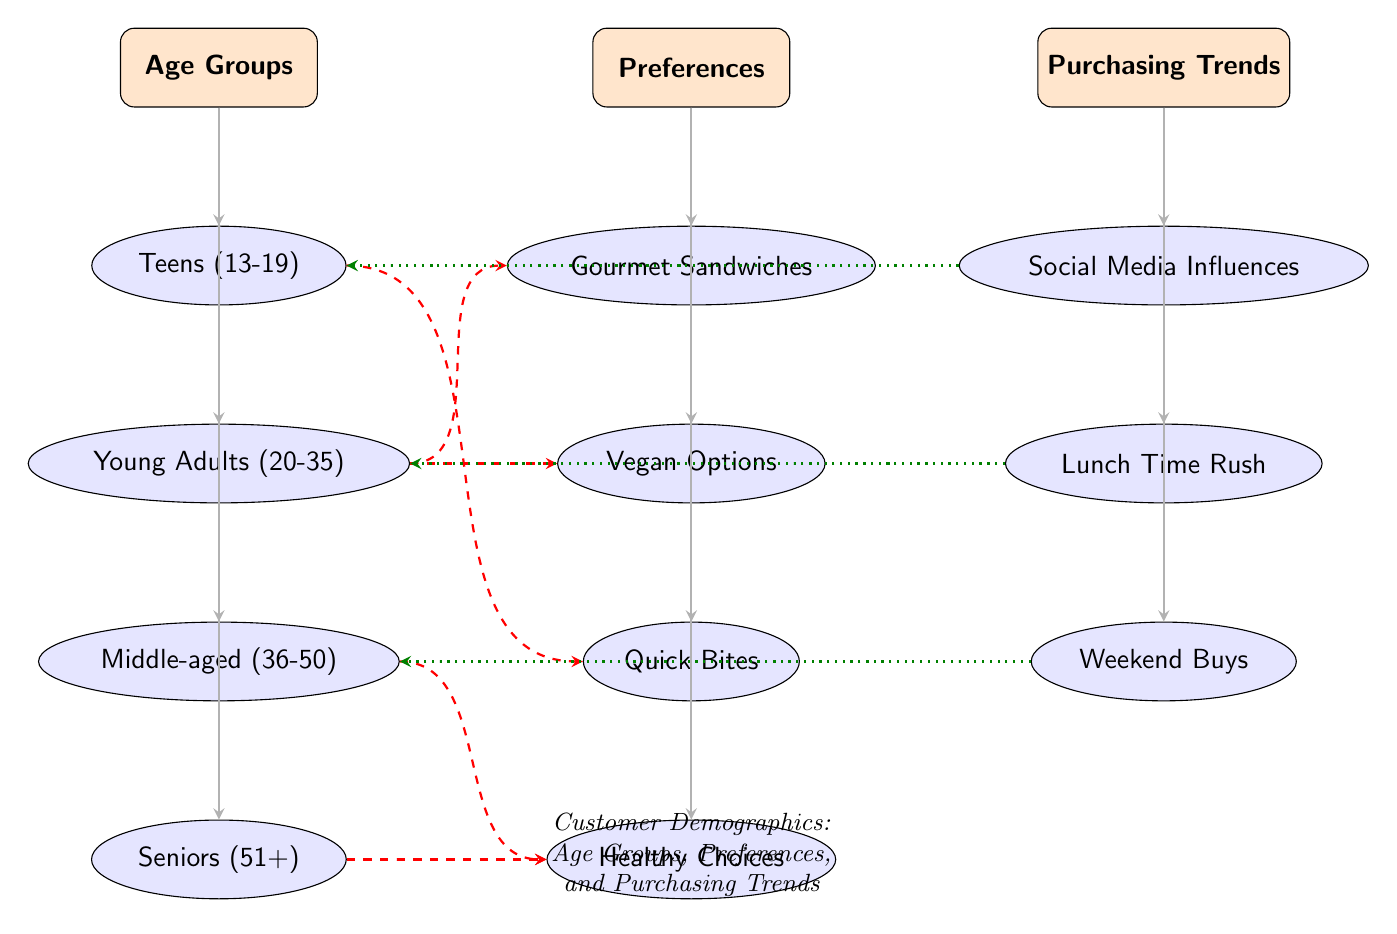What age group is represented below "Age Groups"? The node directly below "Age Groups" is "Teens (13-19)", which indicates the first age group depicted.
Answer: Teens (13-19) How many preference categories are listed? Count the nodes below the "Preferences" main category, which includes gourmet sandwiches, vegan options, quick bites, and healthy choices, giving a total of four categories.
Answer: 4 Which age group is connected to "Quick Bites"? The "Teens (13-19)" node is connected to "Quick Bites" with a dashed edge, indicating a preference relationship.
Answer: Teens (13-19) What is the purchasing trend associated with young adults? The "Lunch Time Rush" is shown to be connected to "Young Adults (20-35)", indicating that this age group exhibits this purchasing behavior.
Answer: Lunch Time Rush Which preference category is linked to middle-aged customers? "Healthy Choices" is connected to "Middle-aged (36-50)", indicating that this age group has an interest in this preference.
Answer: Healthy Choices Which age group does not have any direct connection to "Social Media Influences"? "Seniors (51+)" is the only age group that does not have a direct connection to "Social Media Influences" based on the edges drawn in the diagram.
Answer: Seniors (51+) What is the key relationship displayed between "Young Adults" and "Vegan Options"? Young Adults (20-35) are directly connected to "Vegan Options" with a dashed edge, indicating their preference for this category.
Answer: Vegan Options Which is an example of a purchasing trend linked to middle-aged customers? "Weekend Buys" is personally linked with "Middle-aged (36-50)", showing a specific purchasing trend relevant to that age group.
Answer: Weekend Buys How many main categories are represented in the diagram? There are three main categories represented: Age Groups, Preferences, and Purchasing Trends, evident from the distinct rectangles shown in the diagram.
Answer: 3 